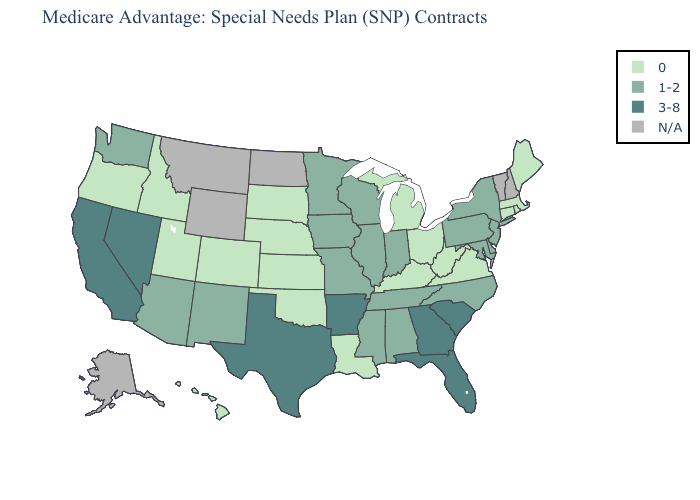Name the states that have a value in the range N/A?
Short answer required. Alaska, Montana, North Dakota, New Hampshire, Vermont, Wyoming. Name the states that have a value in the range 3-8?
Keep it brief. Arkansas, California, Florida, Georgia, Nevada, South Carolina, Texas. What is the value of Oregon?
Be succinct. 0. Among the states that border Minnesota , which have the highest value?
Be succinct. Iowa, Wisconsin. Among the states that border California , which have the lowest value?
Write a very short answer. Oregon. Name the states that have a value in the range 1-2?
Give a very brief answer. Alabama, Arizona, Delaware, Iowa, Illinois, Indiana, Maryland, Minnesota, Missouri, Mississippi, North Carolina, New Jersey, New Mexico, New York, Pennsylvania, Tennessee, Washington, Wisconsin. Does Oregon have the lowest value in the West?
Keep it brief. Yes. Name the states that have a value in the range 0?
Answer briefly. Colorado, Connecticut, Hawaii, Idaho, Kansas, Kentucky, Louisiana, Massachusetts, Maine, Michigan, Nebraska, Ohio, Oklahoma, Oregon, Rhode Island, South Dakota, Utah, Virginia, West Virginia. How many symbols are there in the legend?
Quick response, please. 4. Name the states that have a value in the range 0?
Keep it brief. Colorado, Connecticut, Hawaii, Idaho, Kansas, Kentucky, Louisiana, Massachusetts, Maine, Michigan, Nebraska, Ohio, Oklahoma, Oregon, Rhode Island, South Dakota, Utah, Virginia, West Virginia. Name the states that have a value in the range 3-8?
Keep it brief. Arkansas, California, Florida, Georgia, Nevada, South Carolina, Texas. Which states have the lowest value in the South?
Give a very brief answer. Kentucky, Louisiana, Oklahoma, Virginia, West Virginia. Name the states that have a value in the range 3-8?
Keep it brief. Arkansas, California, Florida, Georgia, Nevada, South Carolina, Texas. 